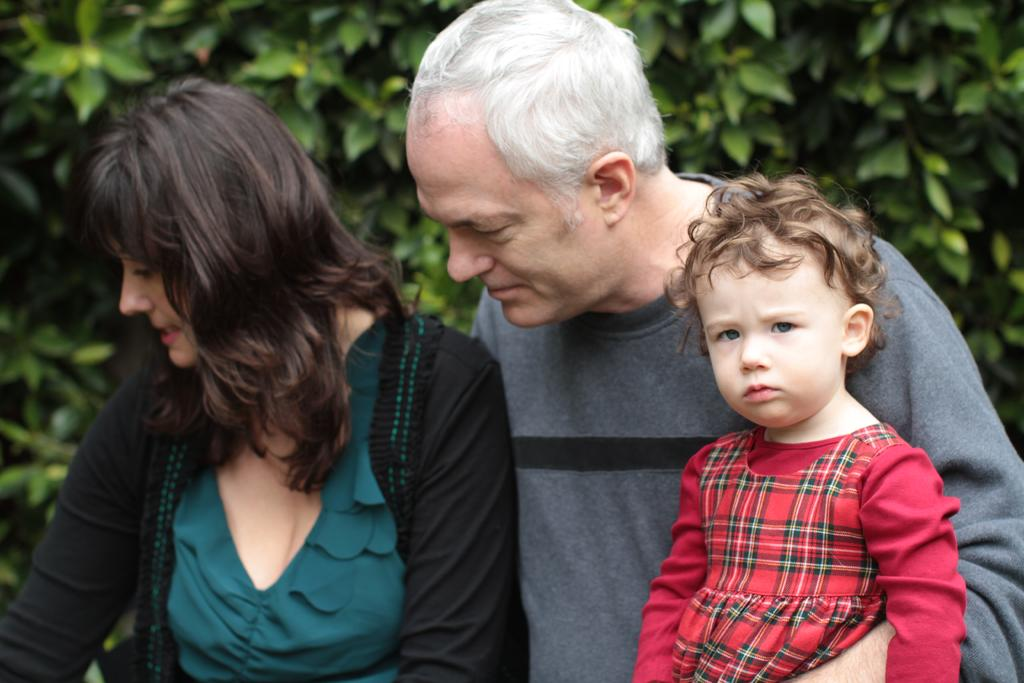What is the gender of the person wearing a red dress in the image? The person wearing a red dress is a kid, and the kid's gender cannot be determined from the image. What are the other people in the image wearing? The man and woman in the image are not described in terms of their clothing. What can be seen in the background of the image? There are trees in the background of the image. What type of sign can be seen in the image? There is no sign present in the image. What is the kid holding in the image? The image does not show the kid holding anything. 